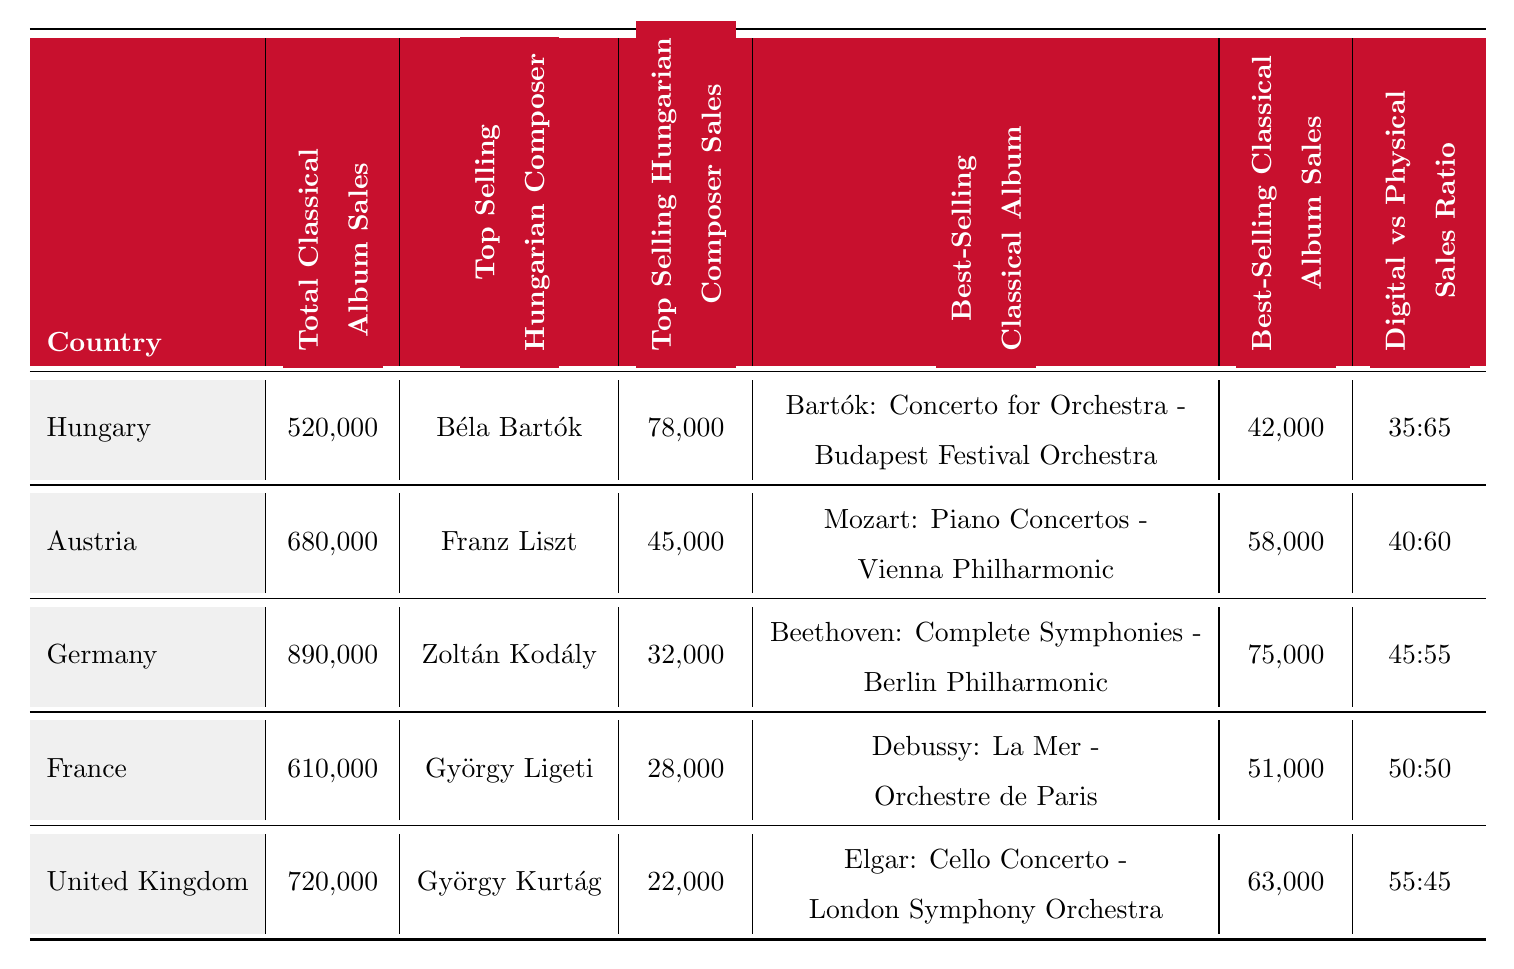What is the total classical album sales in Hungary? The table shows the total classical album sales in Hungary as 520,000.
Answer: 520,000 Who is the top-selling Hungarian composer in Austria? The table lists Franz Liszt as the top-selling Hungarian composer in Austria.
Answer: Franz Liszt How many sales did Zoltán Kodály achieve in Germany? According to the table, Zoltán Kodály had classical album sales of 32,000 in Germany.
Answer: 32,000 Which country had the highest total classical album sales? By comparing the totals, Germany has the highest total classical album sales with 890,000.
Answer: Germany What is the best-selling classical album in the United Kingdom? The table indicates that the best-selling classical album in the United Kingdom is "Elgar: Cello Concerto - London Symphony Orchestra."
Answer: Elgar: Cello Concerto - London Symphony Orchestra How much did the best-selling classical album in France sell? The best-selling classical album in France sold 51,000 copies, as shown in the table.
Answer: 51,000 What is the difference in total album sales between Hungary and Austria? The total classical album sales in Hungary is 520,000 and in Austria, it is 680,000. Thus, the difference is 680,000 - 520,000 = 160,000.
Answer: 160,000 Which country has a digital vs. physical sales ratio of 50:50? The table shows that France has a digital vs. physical sales ratio of 50:50.
Answer: France If we consider only the top-selling Hungarian composers of all countries in the table, who has the highest sales? Looking at the top-selling Hungarian composers: Béla Bartók (78,000), Franz Liszt (45,000), Zoltán Kodály (32,000), György Ligeti (28,000), and György Kurtág (22,000), it is clear that Béla Bartók has the highest sales.
Answer: Béla Bartók Is the best-selling classical album in Hungary from a Hungarian composer? Yes, the best-selling classical album in Hungary is "Bartók: Concerto for Orchestra - Budapest Festival Orchestra," which is by a Hungarian composer, Béla Bartók.
Answer: Yes What is the average best-selling classical album sales across the countries presented? The best-selling album sales are: 42,000 (Hungary), 58,000 (Austria), 75,000 (Germany), 51,000 (France), and 63,000 (United Kingdom). The sum is 42,000 + 58,000 + 75,000 + 51,000 + 63,000 = 289,000. Therefore, the average is 289,000 / 5 = 57,800.
Answer: 57,800 Which country has a lower ratio of digital to physical sales than Hungary? Hungary's digital vs. physical sales ratio is 35:65. Comparing the ratios, Austria (40:60) has a higher ratio, while France (50:50) and the United Kingdom (55:45) also have higher ratios. Only Germany (45:55) has a lower one, but Spain does not appear in the table. Therefore, none in the table are lower than Hungary's ratio.
Answer: None 